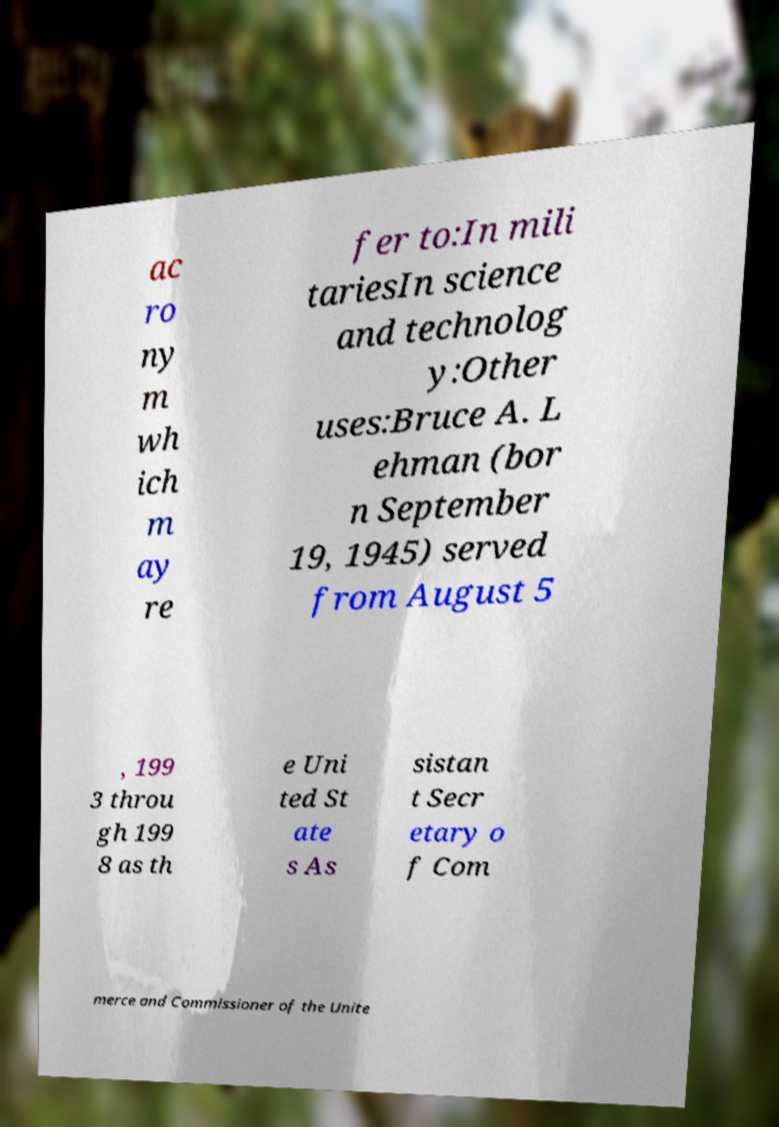Can you accurately transcribe the text from the provided image for me? ac ro ny m wh ich m ay re fer to:In mili tariesIn science and technolog y:Other uses:Bruce A. L ehman (bor n September 19, 1945) served from August 5 , 199 3 throu gh 199 8 as th e Uni ted St ate s As sistan t Secr etary o f Com merce and Commissioner of the Unite 